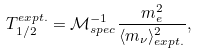Convert formula to latex. <formula><loc_0><loc_0><loc_500><loc_500>T _ { 1 / 2 } ^ { e x p t . } = { \mathcal { M } } _ { s p e c } ^ { - 1 } \frac { m _ { e } ^ { 2 } } { \langle m _ { \nu } \rangle ^ { 2 } _ { e x p t . } } ,</formula> 